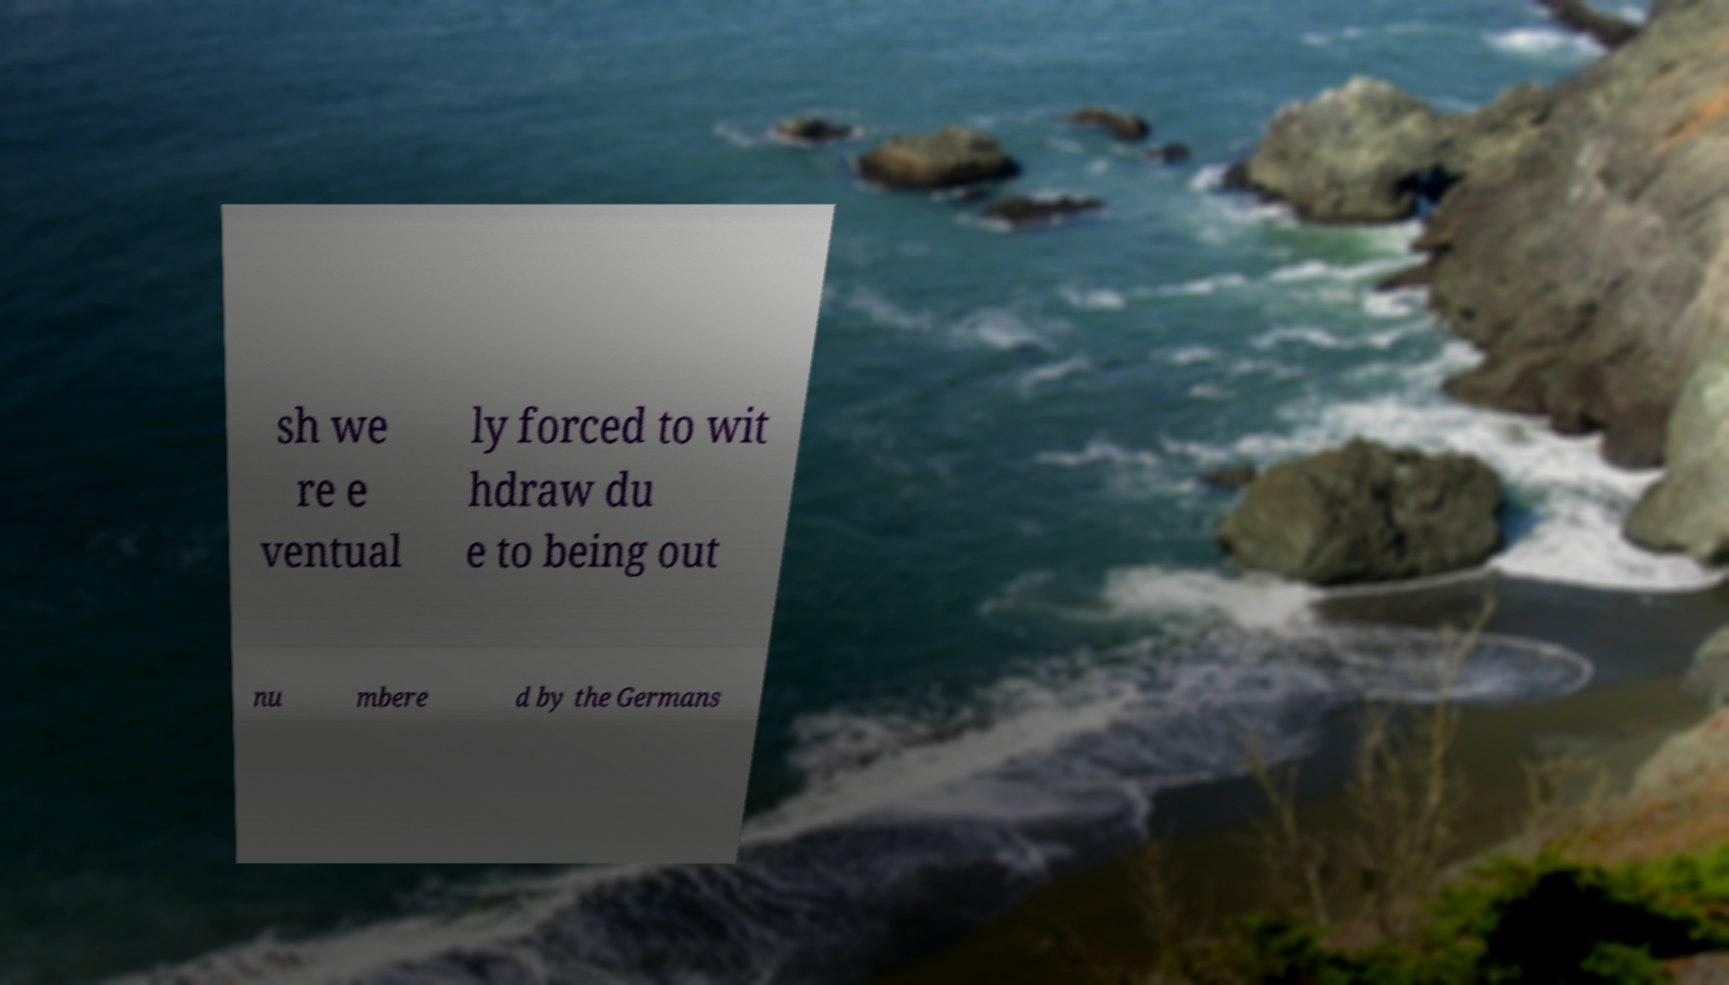Could you extract and type out the text from this image? sh we re e ventual ly forced to wit hdraw du e to being out nu mbere d by the Germans 